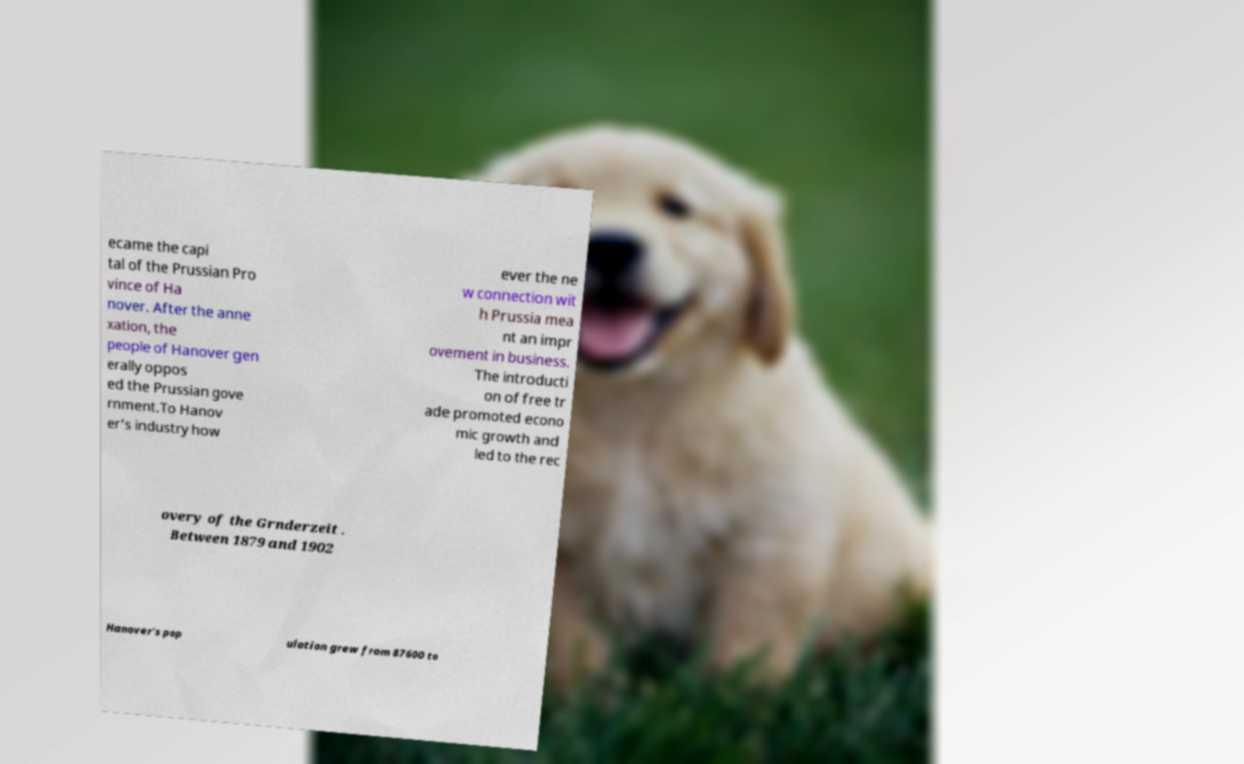Can you read and provide the text displayed in the image?This photo seems to have some interesting text. Can you extract and type it out for me? ecame the capi tal of the Prussian Pro vince of Ha nover. After the anne xation, the people of Hanover gen erally oppos ed the Prussian gove rnment.To Hanov er's industry how ever the ne w connection wit h Prussia mea nt an impr ovement in business. The introducti on of free tr ade promoted econo mic growth and led to the rec overy of the Grnderzeit . Between 1879 and 1902 Hanover's pop ulation grew from 87600 to 